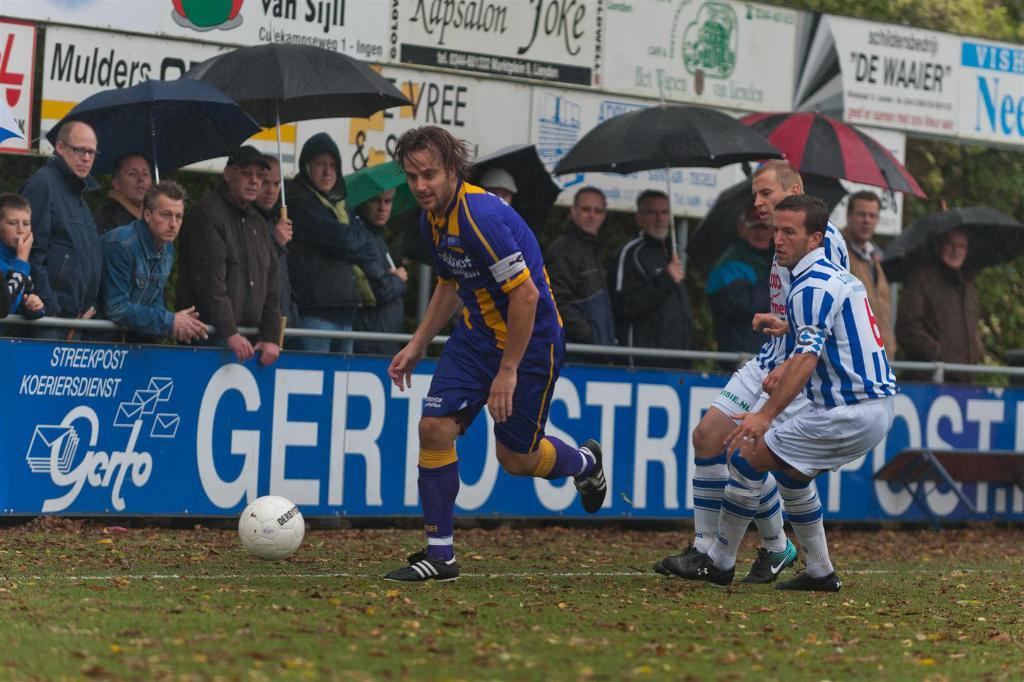<image>
Present a compact description of the photo's key features. A soccer player next to a Goto advertisement 